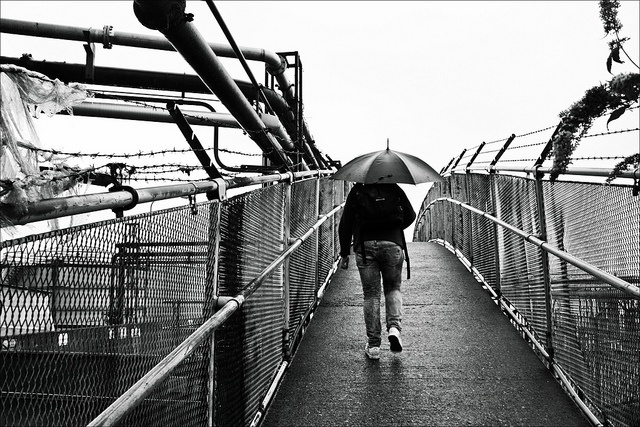Describe the objects in this image and their specific colors. I can see people in gray, black, darkgray, and lightgray tones, umbrella in gray, black, darkgray, and lightgray tones, and backpack in black and gray tones in this image. 